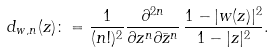Convert formula to latex. <formula><loc_0><loc_0><loc_500><loc_500>d _ { w , n } ( z ) \colon = \frac { 1 } { ( n ! ) ^ { 2 } } \frac { \partial ^ { 2 n } } { \partial z ^ { n } \partial \bar { z } ^ { n } } \, \frac { 1 - | w ( z ) | ^ { 2 } } { 1 - | z | ^ { 2 } } .</formula> 